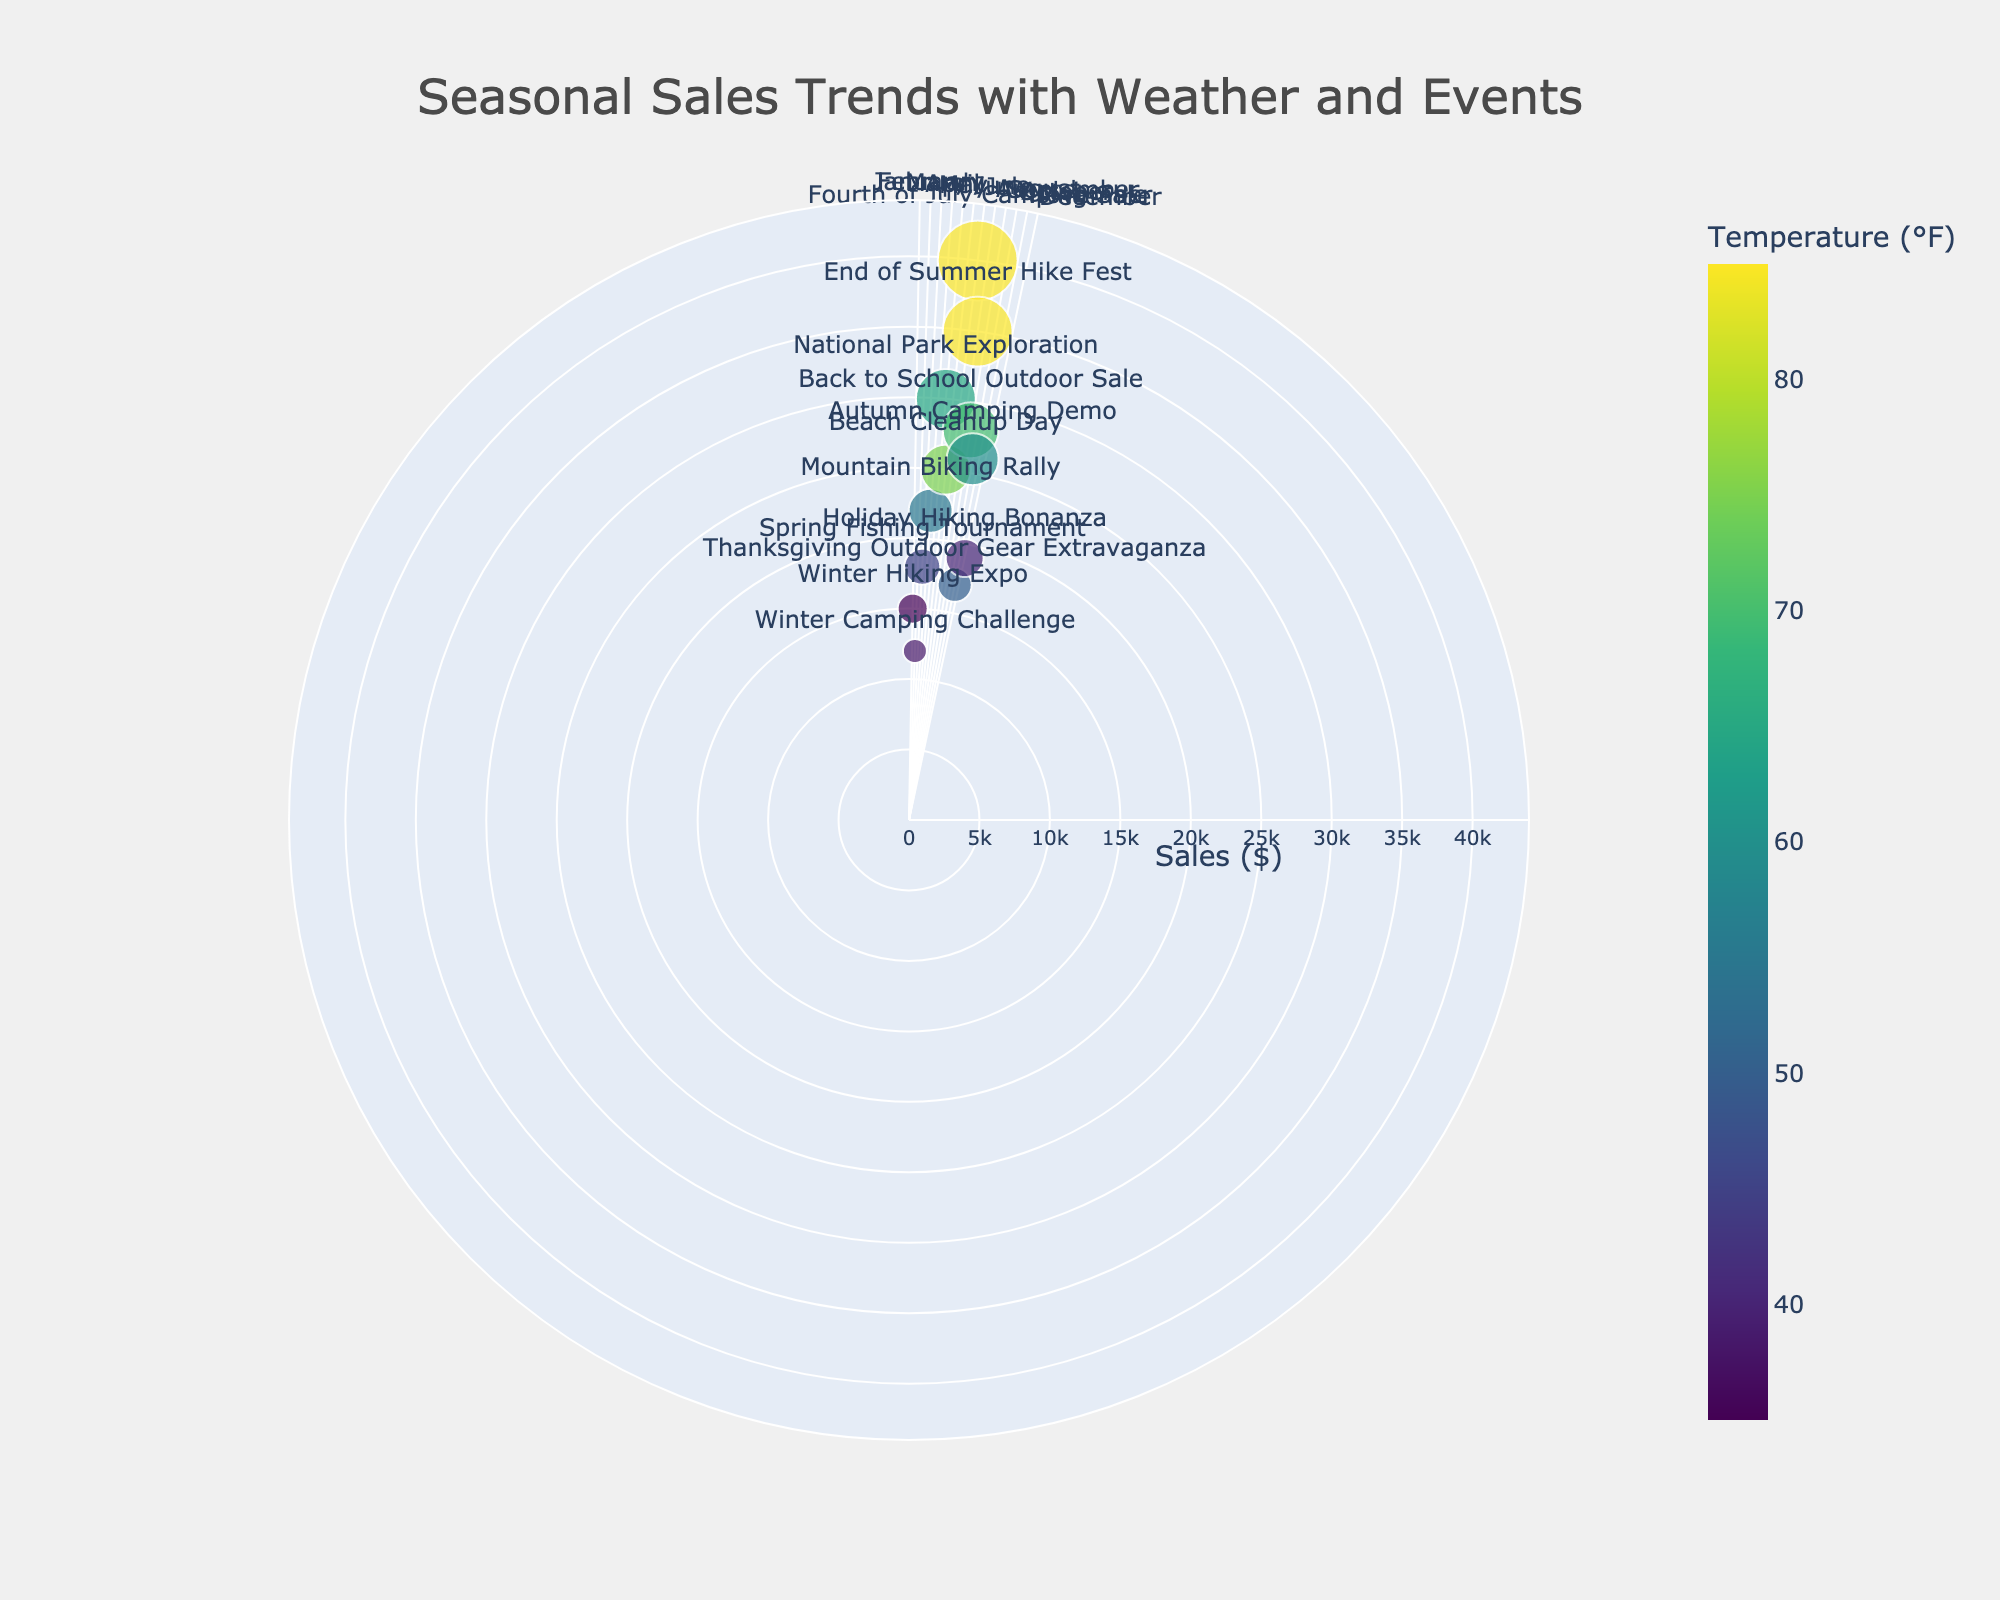What's the title of the chart? The title is located at the top center of the chart. By reading it directly, we can identify the chart's title.
Answer: Seasonal Sales Trends with Weather and Events How many events are shown in the chart? Each data point in the chart corresponds to a different event, and we can count them by looking at the number of unique markers presented.
Answer: 12 Which event has the highest sales, and what are the sales values? Look for the marker with the largest size, and hover over it to read the event's name and sales values from the hover text.
Answer: Fourth of July Camping Sale, $40,000 What's the average sales value for the events held in summer (June, July, August)? Identify the markers for June, July, and August. The sales values are $25,000, $40,000, and $35,000. Summing these gives $100,000, and the average is $100,000 / 3.
Answer: $33,333.33 Which month has the highest precipitation, and what is the value? Look for the month with the highest precipitation value in the hover text, and identify it.
Answer: November, 4.5 inches Is there a correlation between the temperature and the size of the sales markers? Observe the color scale for temperature and compare with the size of the markers to see if higher temperatures generally correspond to larger markers.
Answer: Yes, higher temperatures tend to have larger markers What is the typical (average) precipitation level across all months? Sum all precipitation values: (3.2 + 2.9 + 3.5 + 3.1 + 4.0 + 3.6 + 3.0 + 3.1 + 3.9 + 4.2 + 4.5 + 3.8). The sum is 42.8, dividing by 12 months gives 42.8 / 12.
Answer: 3.57 inches Compare the sales between the hottest month and the coldest month. Which month has higher sales and by how much? Identify the months with the highest and lowest temperature (July and January). Sales in July are $40,000 and in January are $15,000. The difference is $40,000 - $15,000.
Answer: July has higher sales by $25,000 Which events are held during the spring (March, April, May) and what are their sales values? Locate the markers for March, April, and May, hover over them, and read the event names and sales values from the hover text.
Answer: Spring Fishing Tournament ($18,000), Mountain Biking Rally ($22,000), National Park Exploration ($30,000) What's the median sales value for all events? List all sales values: $15,000, $12,000, $18,000, $22,000, $30,000, $25,000, $40,000, $35,000, $28,000, $26,000, $17,000, $19,000. Sorting them: $12,000, $15,000, $17,000, $18,000, $19,000, $22,000, $25,000, $26,000, $28,000, $30,000, $35,000, $40,000. The median is the average of the 6th and 7th values: ($22,000 + $25,000) / 2.
Answer: $23,500 